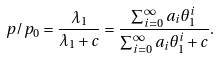Convert formula to latex. <formula><loc_0><loc_0><loc_500><loc_500>p / p _ { 0 } = \frac { \lambda _ { 1 } } { \lambda _ { 1 } + c } = \frac { \sum _ { i = 0 } ^ { \infty } a _ { i } \theta _ { 1 } ^ { i } } { \sum _ { i = 0 } ^ { \infty } a _ { i } \theta _ { 1 } ^ { i } + c } .</formula> 